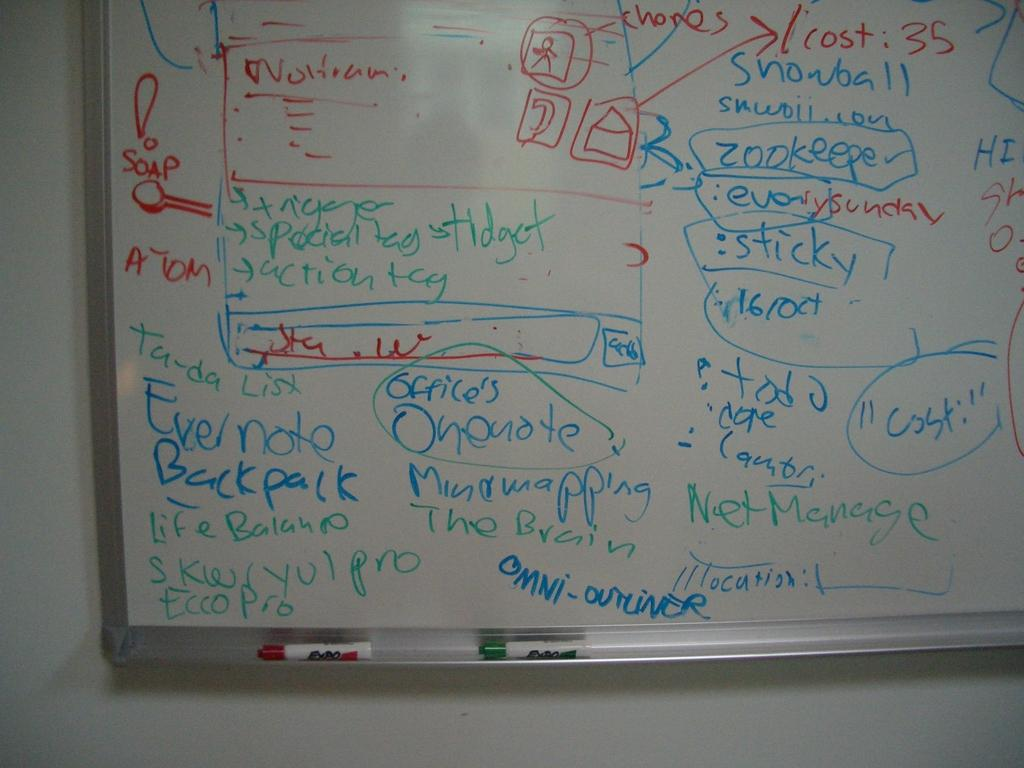<image>
Render a clear and concise summary of the photo. A whiteboard with much written in blue ink including backpack and onenote. 